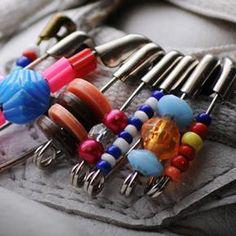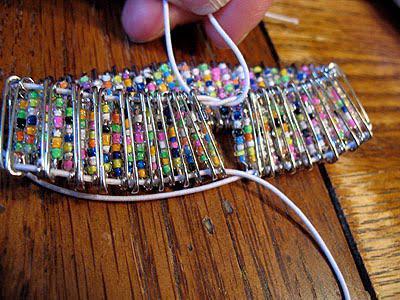The first image is the image on the left, the second image is the image on the right. Given the left and right images, does the statement "In one of the images there is a group of beaded safety pins that reveal a particular shape." hold true? Answer yes or no. No. 